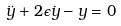Convert formula to latex. <formula><loc_0><loc_0><loc_500><loc_500>\ddot { y } + 2 { \epsilon } \dot { y } - y = 0</formula> 